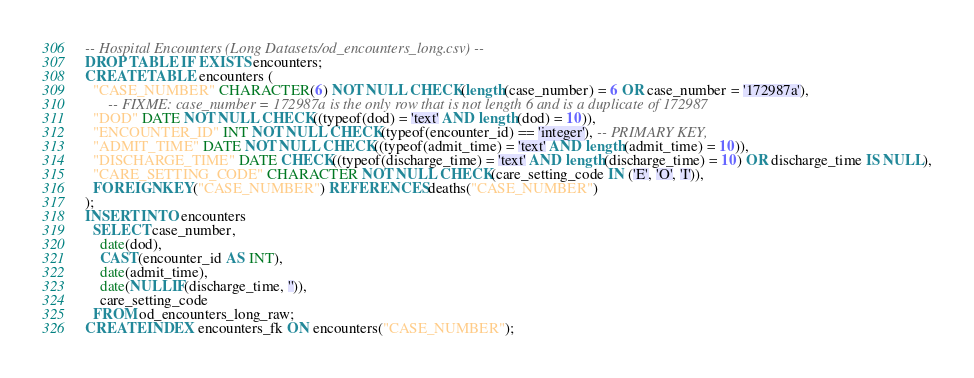<code> <loc_0><loc_0><loc_500><loc_500><_SQL_>-- Hospital Encounters (Long Datasets/od_encounters_long.csv) --
DROP TABLE IF EXISTS encounters;
CREATE TABLE encounters (
  "CASE_NUMBER" CHARACTER(6) NOT NULL CHECK(length(case_number) = 6 OR case_number = '172987a'),
      -- FIXME: case_number = 172987a is the only row that is not length 6 and is a duplicate of 172987
  "DOD" DATE NOT NULL CHECK((typeof(dod) = 'text' AND length(dod) = 10)),
  "ENCOUNTER_ID" INT NOT NULL CHECK(typeof(encounter_id) == 'integer'), -- PRIMARY KEY,
  "ADMIT_TIME" DATE NOT NULL CHECK((typeof(admit_time) = 'text' AND length(admit_time) = 10)),
  "DISCHARGE_TIME" DATE CHECK((typeof(discharge_time) = 'text' AND length(discharge_time) = 10) OR discharge_time IS NULL),
  "CARE_SETTING_CODE" CHARACTER NOT NULL CHECK(care_setting_code IN ('E', 'O', 'I')),
  FOREIGN KEY("CASE_NUMBER") REFERENCES deaths("CASE_NUMBER")
);
INSERT INTO encounters
  SELECT case_number,
    date(dod),
    CAST(encounter_id AS INT),
    date(admit_time),
    date(NULLIF(discharge_time, '')),
    care_setting_code
  FROM od_encounters_long_raw;
CREATE INDEX encounters_fk ON encounters("CASE_NUMBER");
</code> 